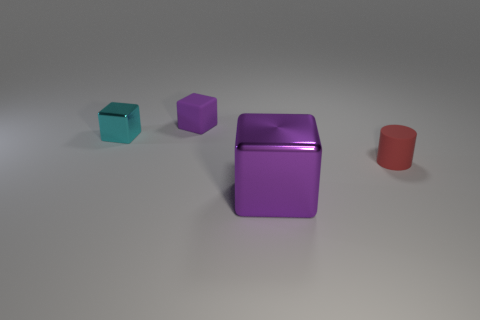Add 1 large brown matte spheres. How many objects exist? 5 Subtract all blocks. How many objects are left? 1 Add 2 small cylinders. How many small cylinders are left? 3 Add 2 cyan objects. How many cyan objects exist? 3 Subtract 0 blue cylinders. How many objects are left? 4 Subtract all cyan things. Subtract all metallic things. How many objects are left? 1 